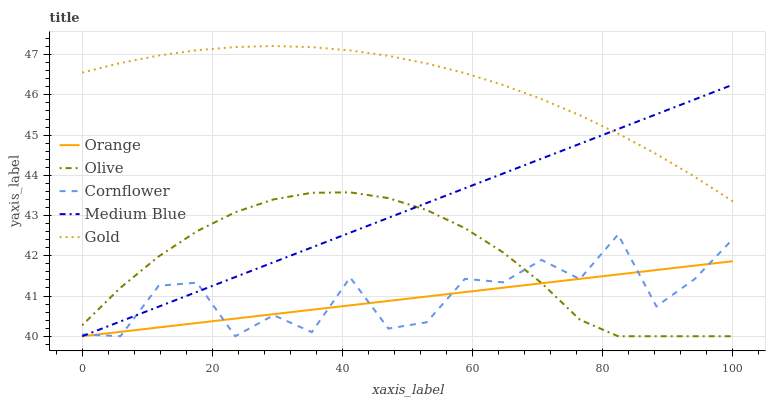Does Orange have the minimum area under the curve?
Answer yes or no. Yes. Does Gold have the maximum area under the curve?
Answer yes or no. Yes. Does Olive have the minimum area under the curve?
Answer yes or no. No. Does Olive have the maximum area under the curve?
Answer yes or no. No. Is Medium Blue the smoothest?
Answer yes or no. Yes. Is Cornflower the roughest?
Answer yes or no. Yes. Is Olive the smoothest?
Answer yes or no. No. Is Olive the roughest?
Answer yes or no. No. Does Orange have the lowest value?
Answer yes or no. Yes. Does Gold have the lowest value?
Answer yes or no. No. Does Gold have the highest value?
Answer yes or no. Yes. Does Olive have the highest value?
Answer yes or no. No. Is Cornflower less than Gold?
Answer yes or no. Yes. Is Gold greater than Orange?
Answer yes or no. Yes. Does Gold intersect Medium Blue?
Answer yes or no. Yes. Is Gold less than Medium Blue?
Answer yes or no. No. Is Gold greater than Medium Blue?
Answer yes or no. No. Does Cornflower intersect Gold?
Answer yes or no. No. 